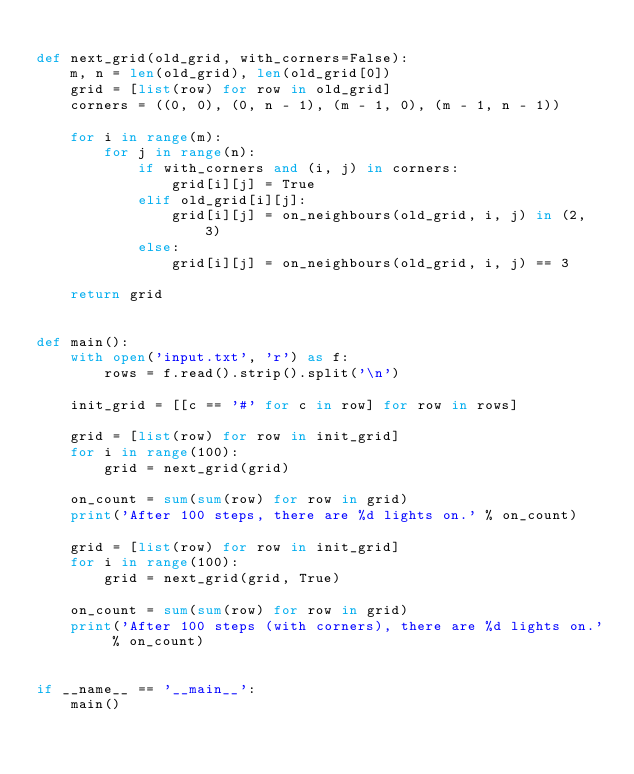<code> <loc_0><loc_0><loc_500><loc_500><_Python_>
def next_grid(old_grid, with_corners=False):
    m, n = len(old_grid), len(old_grid[0])
    grid = [list(row) for row in old_grid]
    corners = ((0, 0), (0, n - 1), (m - 1, 0), (m - 1, n - 1))

    for i in range(m):
        for j in range(n):
            if with_corners and (i, j) in corners:
                grid[i][j] = True
            elif old_grid[i][j]:
                grid[i][j] = on_neighbours(old_grid, i, j) in (2, 3)
            else:
                grid[i][j] = on_neighbours(old_grid, i, j) == 3

    return grid


def main():
    with open('input.txt', 'r') as f:
        rows = f.read().strip().split('\n')

    init_grid = [[c == '#' for c in row] for row in rows]

    grid = [list(row) for row in init_grid]
    for i in range(100):
        grid = next_grid(grid)

    on_count = sum(sum(row) for row in grid)
    print('After 100 steps, there are %d lights on.' % on_count)

    grid = [list(row) for row in init_grid]
    for i in range(100):
        grid = next_grid(grid, True)

    on_count = sum(sum(row) for row in grid)
    print('After 100 steps (with corners), there are %d lights on.' % on_count)


if __name__ == '__main__':
    main()
</code> 